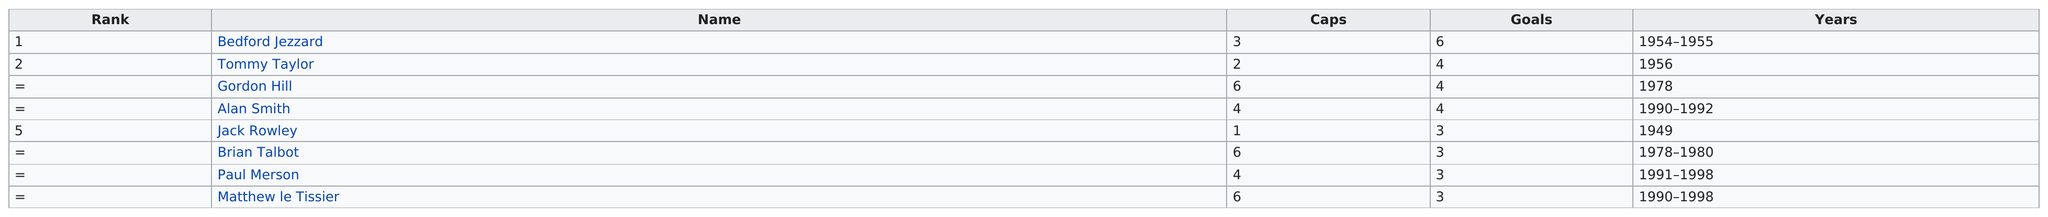Specify some key components in this picture. Gordon Hill, Brian Talbot, and Matthew le Tissier were the players who had the most caps, respectively. Alan Smith is listed after Jack Rowley in the contact list. Tommy Taylor had an equal number of goals as Gordon Hill and Alan Smith. Matthew le Tissier's name is listed last. The name that is listed before Brian Talbot is Jack Rowley. 